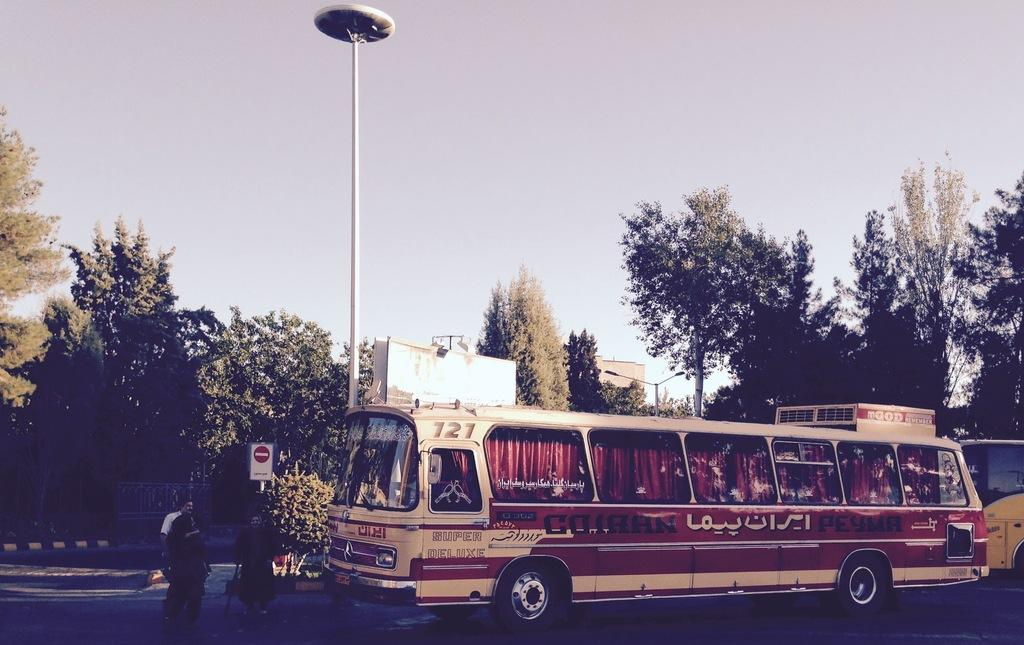Provide a one-sentence caption for the provided image. A tan and brown bus sitting at a street corner with Arabic writing on it. 